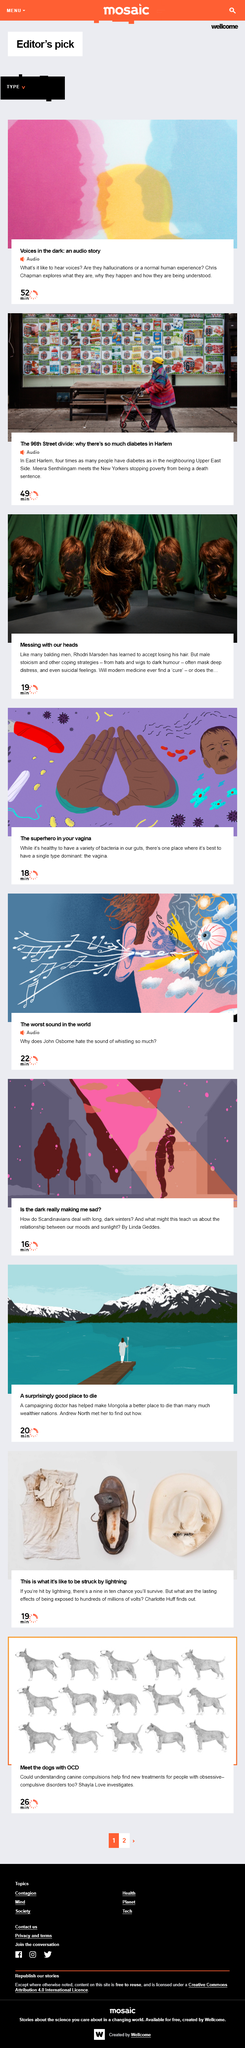Point out several critical features in this image. The audio story Voices in the Dark: an audio story is 52 minutes long. Chris Chapman explores what it is like to hear voices. People who live in East Harlem are four times more likely to have diabetes than those who reside on the Upper East Side. 